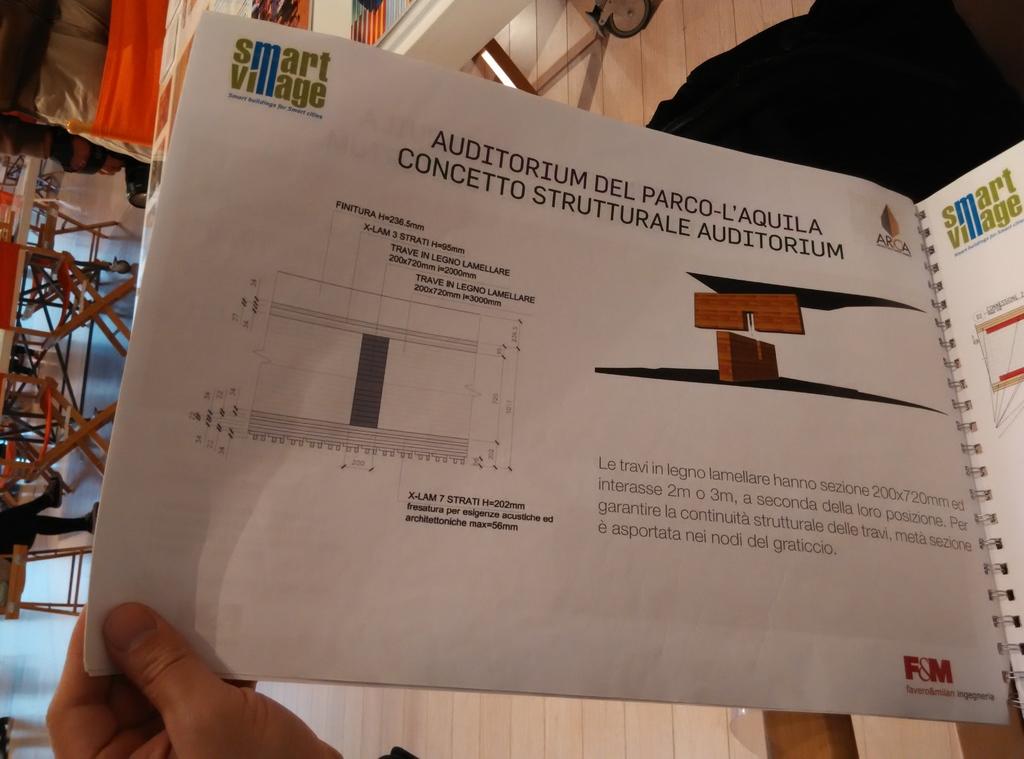What is the brand?
Keep it short and to the point. Smart village. 